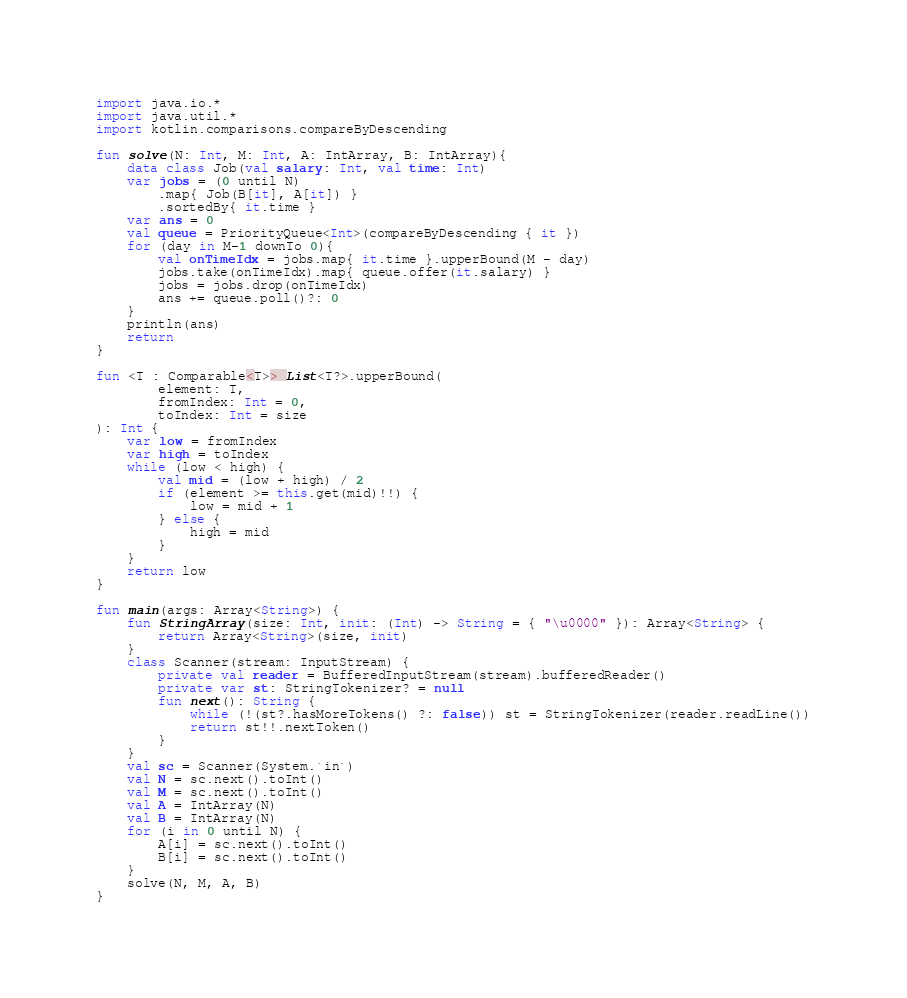<code> <loc_0><loc_0><loc_500><loc_500><_Kotlin_>import java.io.*
import java.util.*
import kotlin.comparisons.compareByDescending

fun solve(N: Int, M: Int, A: IntArray, B: IntArray){
    data class Job(val salary: Int, val time: Int)
    var jobs = (0 until N)
        .map{ Job(B[it], A[it]) }
        .sortedBy{ it.time }
    var ans = 0
    val queue = PriorityQueue<Int>(compareByDescending { it })
    for (day in M-1 downTo 0){
        val onTimeIdx = jobs.map{ it.time }.upperBound(M - day)
        jobs.take(onTimeIdx).map{ queue.offer(it.salary) }
        jobs = jobs.drop(onTimeIdx)
        ans += queue.poll()?: 0
    }
    println(ans)
    return
}

fun <T : Comparable<T>> List<T?>.upperBound(
        element: T,
        fromIndex: Int = 0,
        toIndex: Int = size
): Int {
    var low = fromIndex
    var high = toIndex
    while (low < high) {
        val mid = (low + high) / 2
        if (element >= this.get(mid)!!) {
            low = mid + 1
        } else {
            high = mid
        }
    }
    return low
}

fun main(args: Array<String>) {
    fun StringArray(size: Int, init: (Int) -> String = { "\u0000" }): Array<String> {
        return Array<String>(size, init)
    }
    class Scanner(stream: InputStream) {
        private val reader = BufferedInputStream(stream).bufferedReader()
        private var st: StringTokenizer? = null
        fun next(): String {
            while (!(st?.hasMoreTokens() ?: false)) st = StringTokenizer(reader.readLine())
            return st!!.nextToken()
        }
    }
    val sc = Scanner(System.`in`)
    val N = sc.next().toInt()
    val M = sc.next().toInt()
    val A = IntArray(N)
    val B = IntArray(N)
    for (i in 0 until N) {
        A[i] = sc.next().toInt()
        B[i] = sc.next().toInt()
    }
    solve(N, M, A, B)
}
</code> 